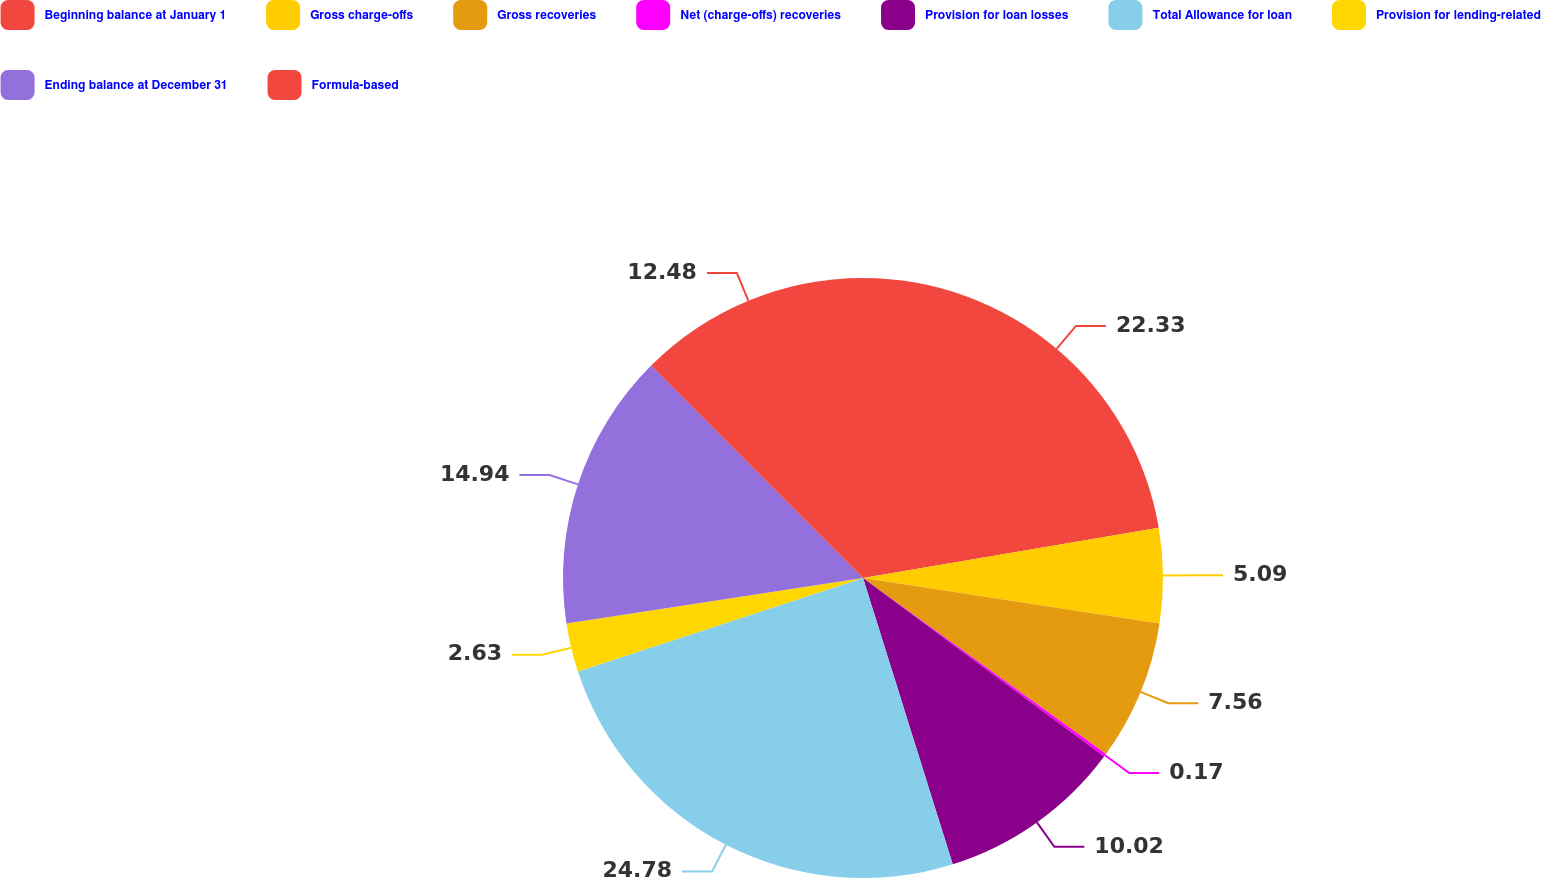<chart> <loc_0><loc_0><loc_500><loc_500><pie_chart><fcel>Beginning balance at January 1<fcel>Gross charge-offs<fcel>Gross recoveries<fcel>Net (charge-offs) recoveries<fcel>Provision for loan losses<fcel>Total Allowance for loan<fcel>Provision for lending-related<fcel>Ending balance at December 31<fcel>Formula-based<nl><fcel>22.33%<fcel>5.09%<fcel>7.56%<fcel>0.17%<fcel>10.02%<fcel>24.79%<fcel>2.63%<fcel>14.94%<fcel>12.48%<nl></chart> 